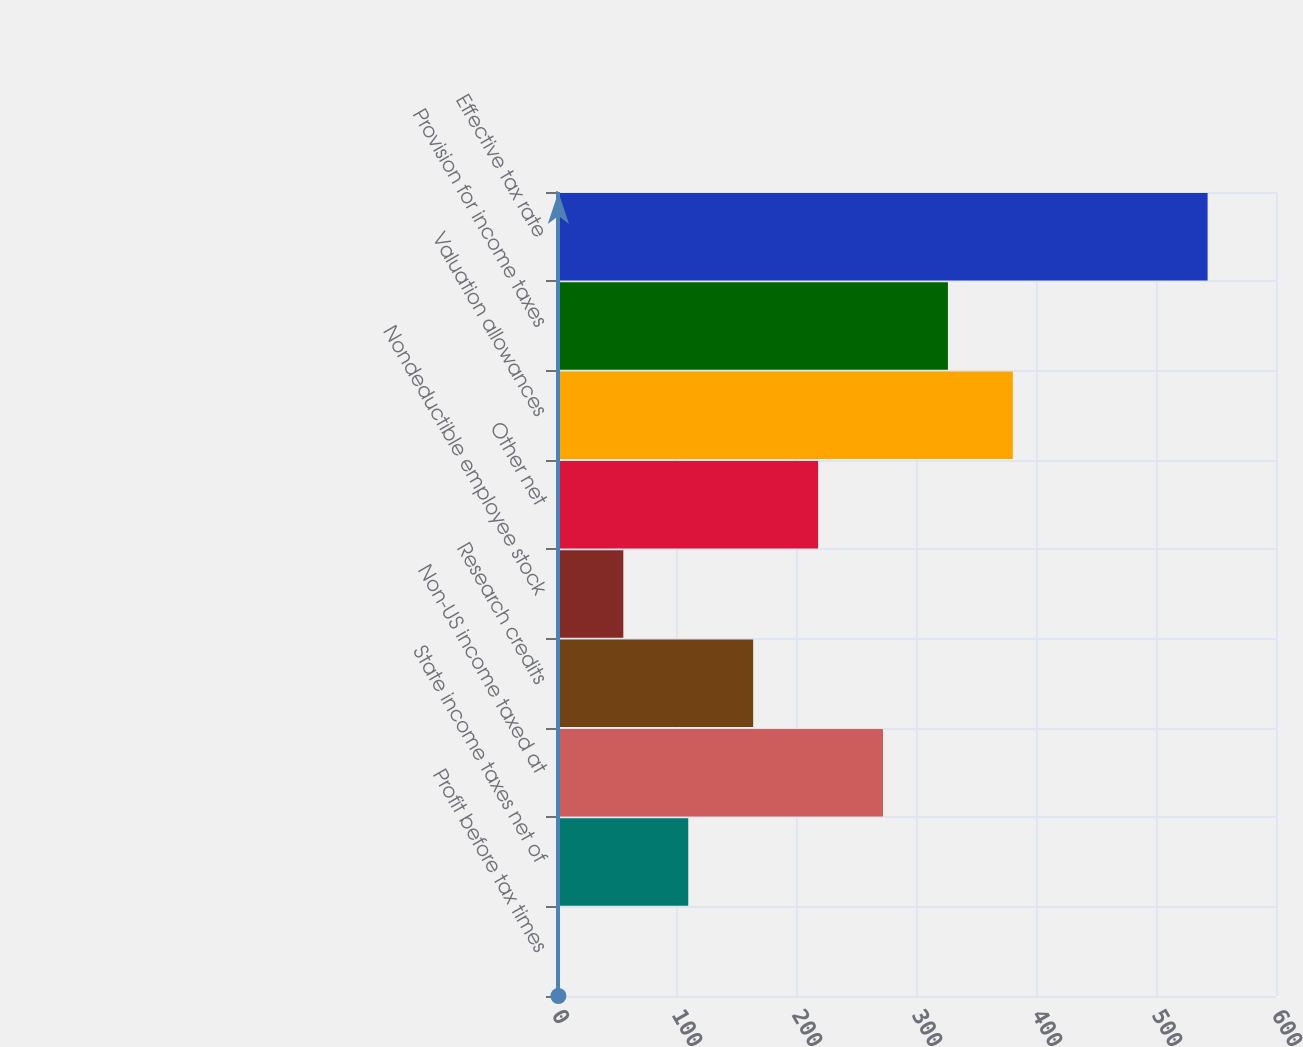<chart> <loc_0><loc_0><loc_500><loc_500><bar_chart><fcel>Profit before tax times<fcel>State income taxes net of<fcel>Non-US income taxed at<fcel>Research credits<fcel>Nondeductible employee stock<fcel>Other net<fcel>Valuation allowances<fcel>Provision for income taxes<fcel>Effective tax rate<nl><fcel>2<fcel>110.2<fcel>272.5<fcel>164.3<fcel>56.1<fcel>218.4<fcel>380.7<fcel>326.6<fcel>543<nl></chart> 